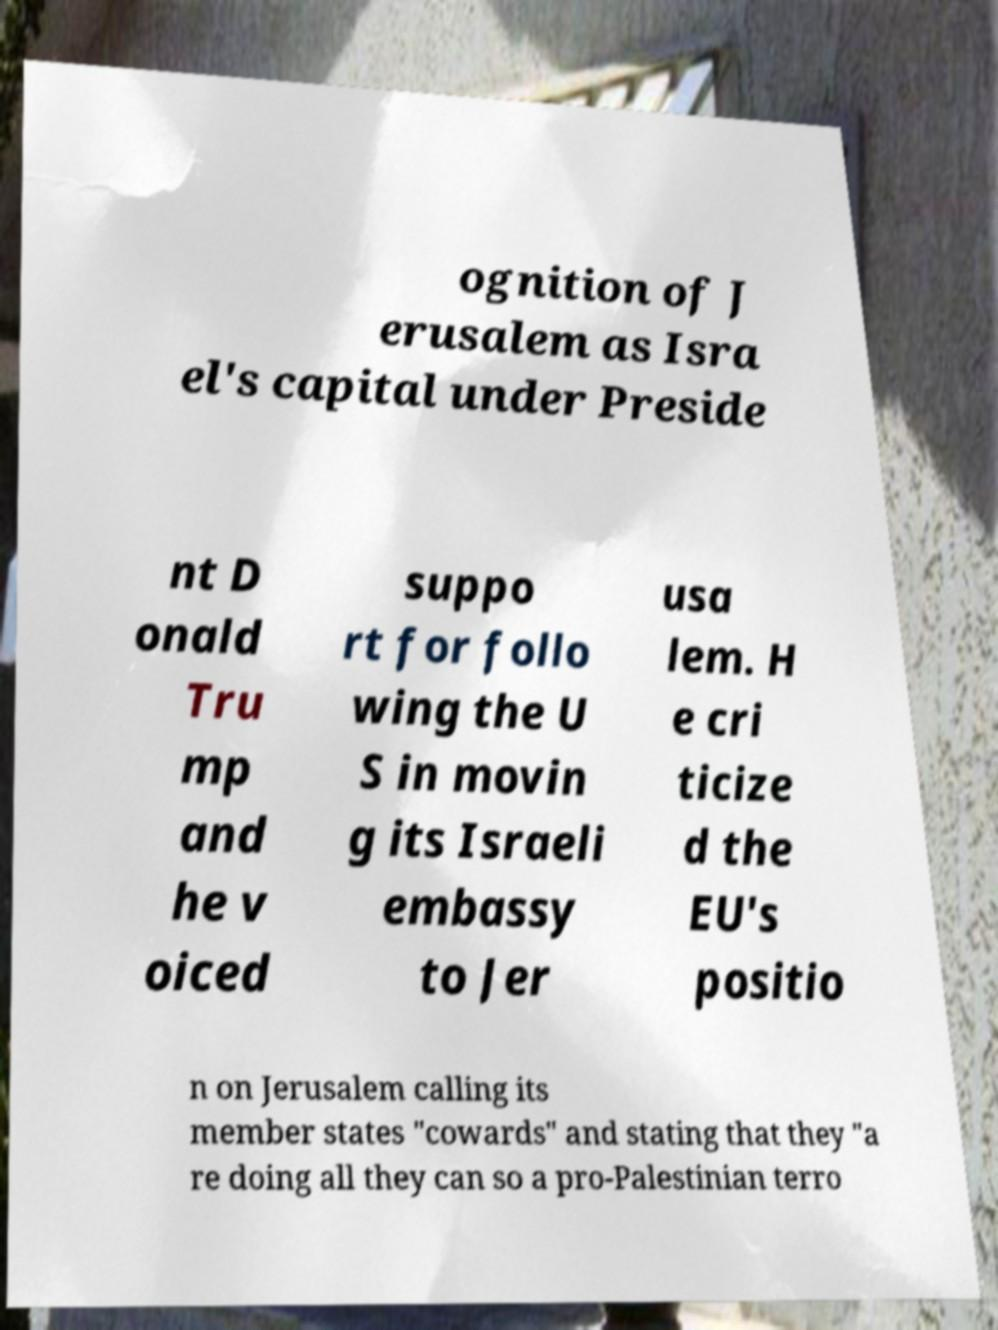Can you accurately transcribe the text from the provided image for me? ognition of J erusalem as Isra el's capital under Preside nt D onald Tru mp and he v oiced suppo rt for follo wing the U S in movin g its Israeli embassy to Jer usa lem. H e cri ticize d the EU's positio n on Jerusalem calling its member states "cowards" and stating that they "a re doing all they can so a pro-Palestinian terro 